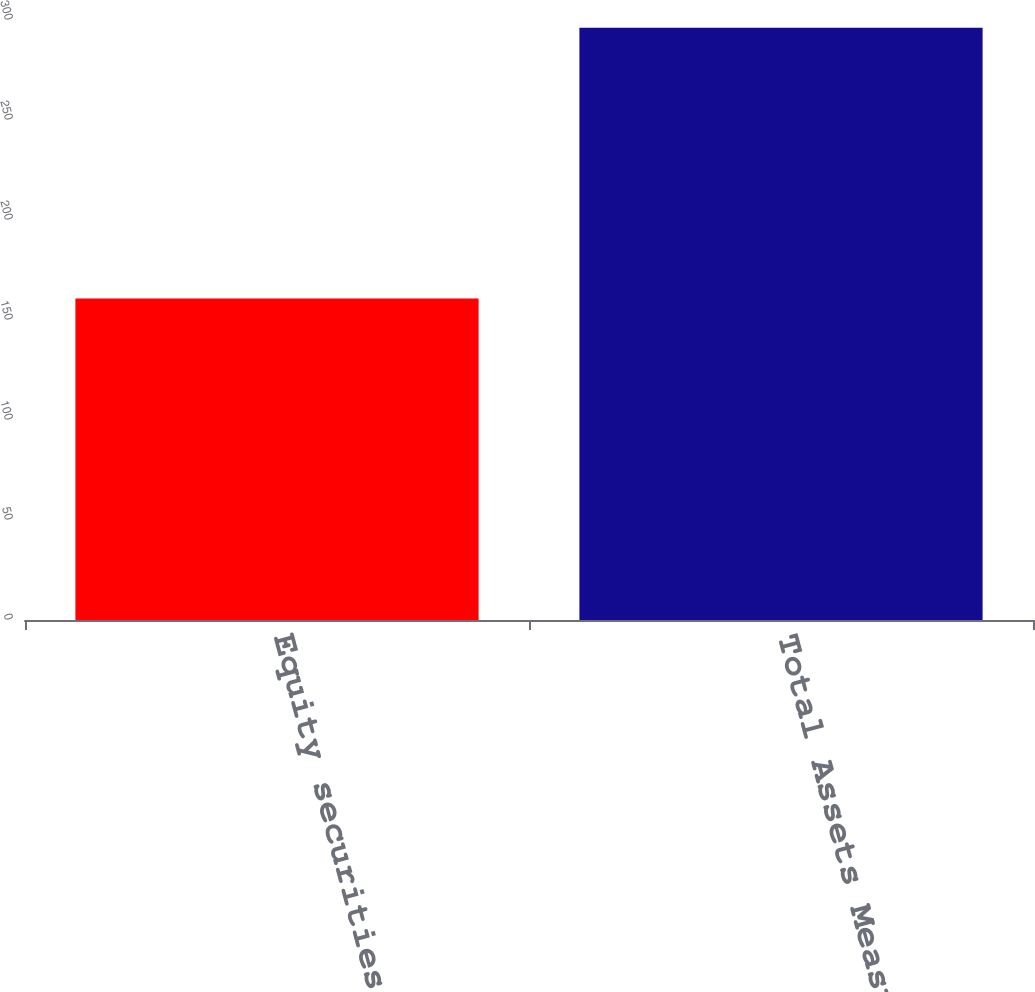Convert chart to OTSL. <chart><loc_0><loc_0><loc_500><loc_500><bar_chart><fcel>Equity securities<fcel>Total Assets Measured at Fair<nl><fcel>160.7<fcel>296.1<nl></chart> 